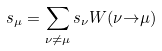<formula> <loc_0><loc_0><loc_500><loc_500>s _ { \mu } = \sum _ { \nu \neq \mu } s _ { \nu } W ( \nu { \to } \mu )</formula> 